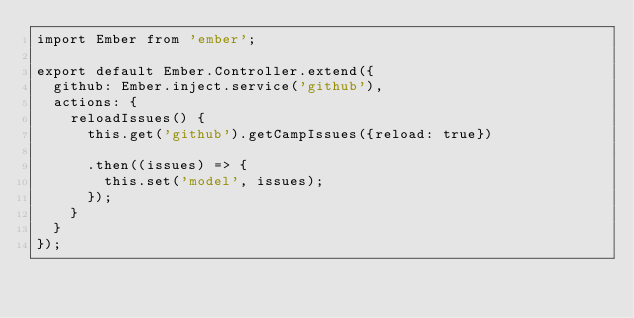<code> <loc_0><loc_0><loc_500><loc_500><_JavaScript_>import Ember from 'ember';

export default Ember.Controller.extend({
  github: Ember.inject.service('github'),
  actions: {
    reloadIssues() {
      this.get('github').getCampIssues({reload: true})

      .then((issues) => {
        this.set('model', issues);
      });
    }
  }
});
</code> 